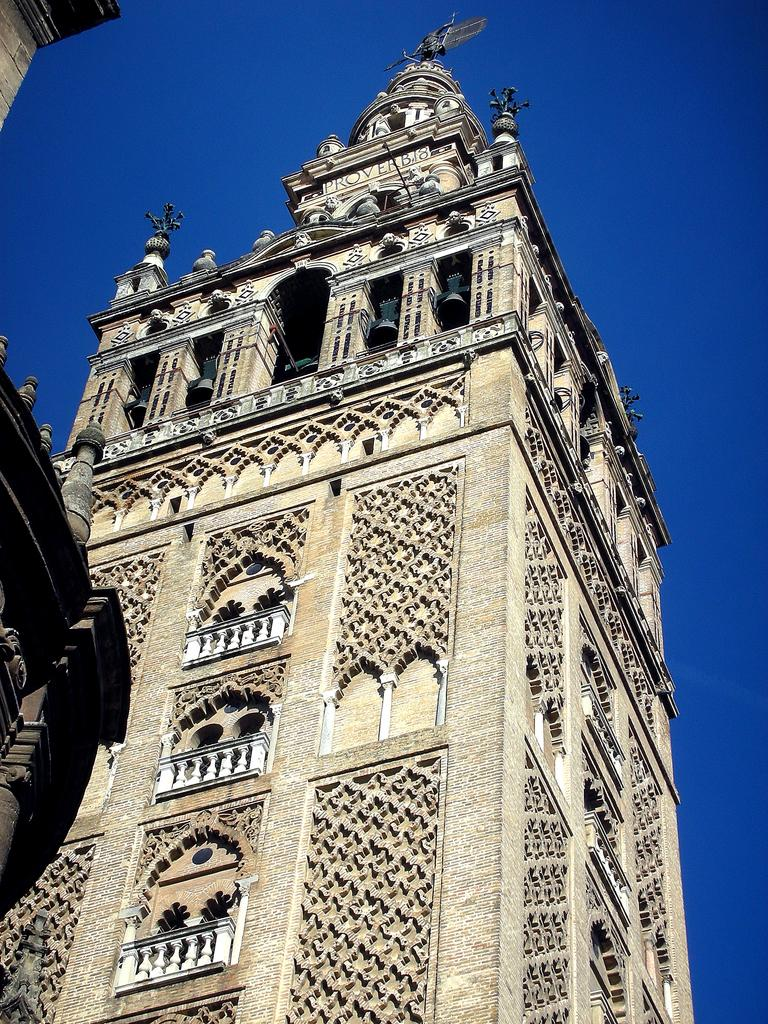What type of structures are present in the image? There are buildings in the image. Can you describe any specific features of the buildings? The buildings have windows and grilles. Is there any artwork or decoration on the buildings? Yes, there is a statue at the top of a building. What can be seen in the background of the image? The sky is visible in the image. What type of sweater is the sand wearing in the image? There is no sweater or sand present in the image; it features buildings with a statue and the sky in the background. 